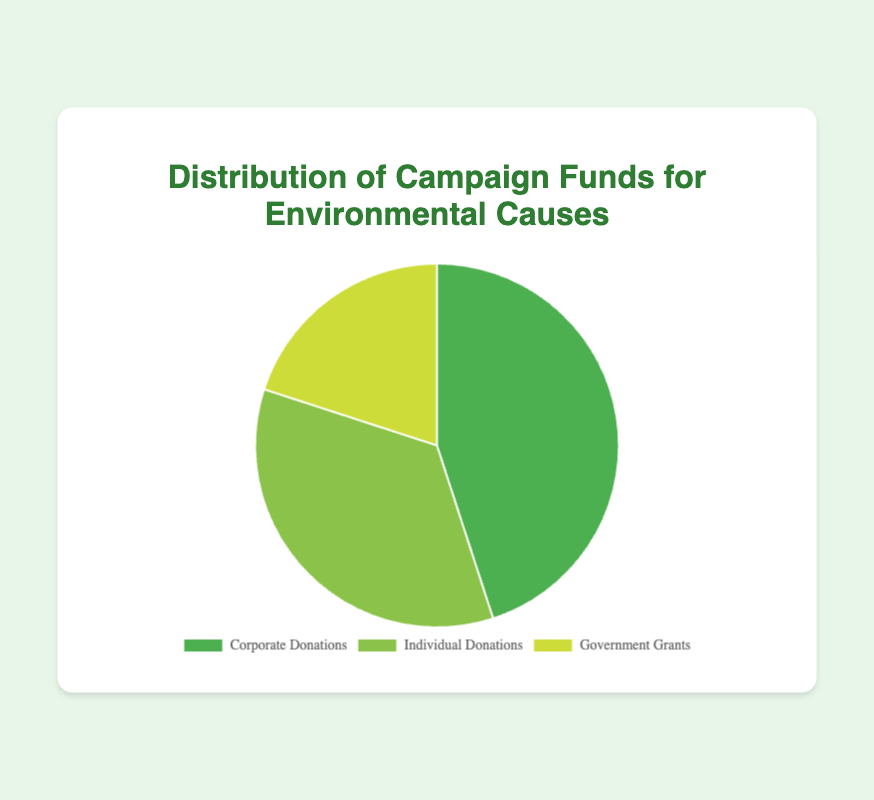Which source type contributes the most to the campaign funds? The pie chart shows that Corporate Donations contribute the largest portion, which is 45% of the total campaign funds.
Answer: Corporate Donations What percentage of the campaign funds comes from Government Grants? By looking at the pie chart, we can see the slice corresponding to Government Grants which is 20% of the total campaign funds.
Answer: 20% Which two sources combined contribute to 80% of the campaign funds? Adding Corporate Donations (45%) and Individual Donations (35%), we get 45% + 35% = 80%.
Answer: Corporate Donations and Individual Donations How much more does Corporate Donations contribute compared to Government Grants? According to the chart, Corporate Donations are 45% and Government Grants are 20%. The difference is 45% - 20% = 25%.
Answer: 25% What is the total percentage of funds donated by individuals and governments combined? Individual Donations contribute 35%, and Government Grants contribute 20%. Adding these percentages gives us 35% + 20% = 55%.
Answer: 55% What portion of the funds comes from non-corporate sources? Non-corporate sources include Individual Donations (35%) and Government Grants (20%). Adding these percentages gives us 35% + 20% = 55%.
Answer: 55% Is there a source type that contributes less than 30% to the campaign funds? The pie chart shows Government Grants contribute 20%, which is less than 30%.
Answer: Government Grants Which source type is second in terms of its contribution to the campaign funds? The pie chart indicates that Individual Donations contribute 35%, which is the second highest after Corporate Donations (45%).
Answer: Individual Donations 